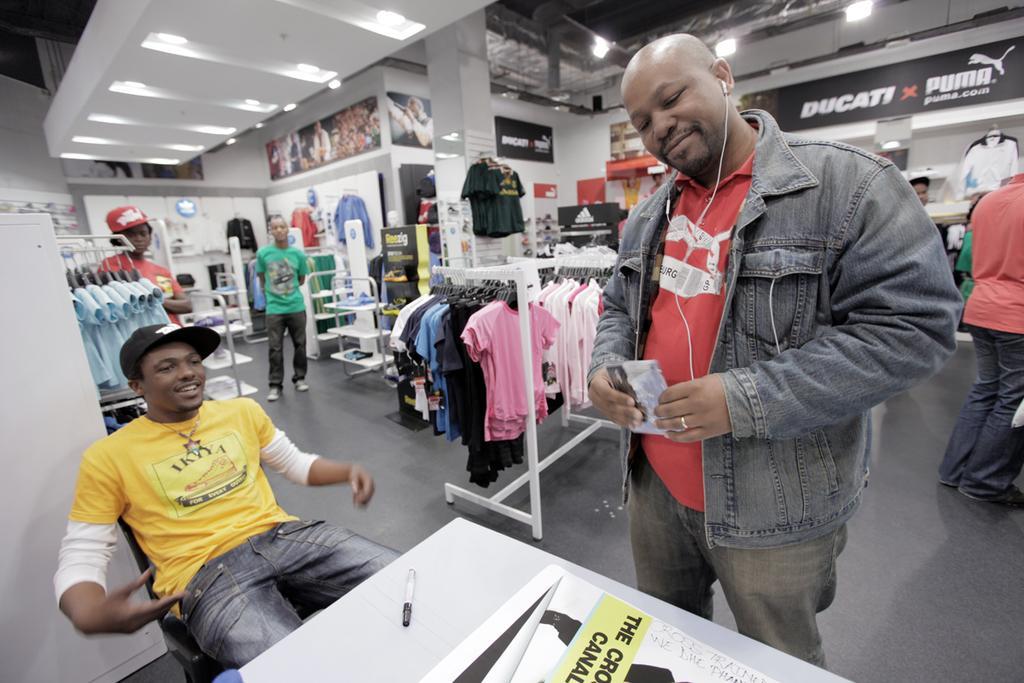Could you give a brief overview of what you see in this image? It is a clothing store and there is a collection of different brands of clothes and in the front there is a table and a person is sitting on the chair in front of the table,beside him there is a man Standing and there are few other people behind the man in the store. 